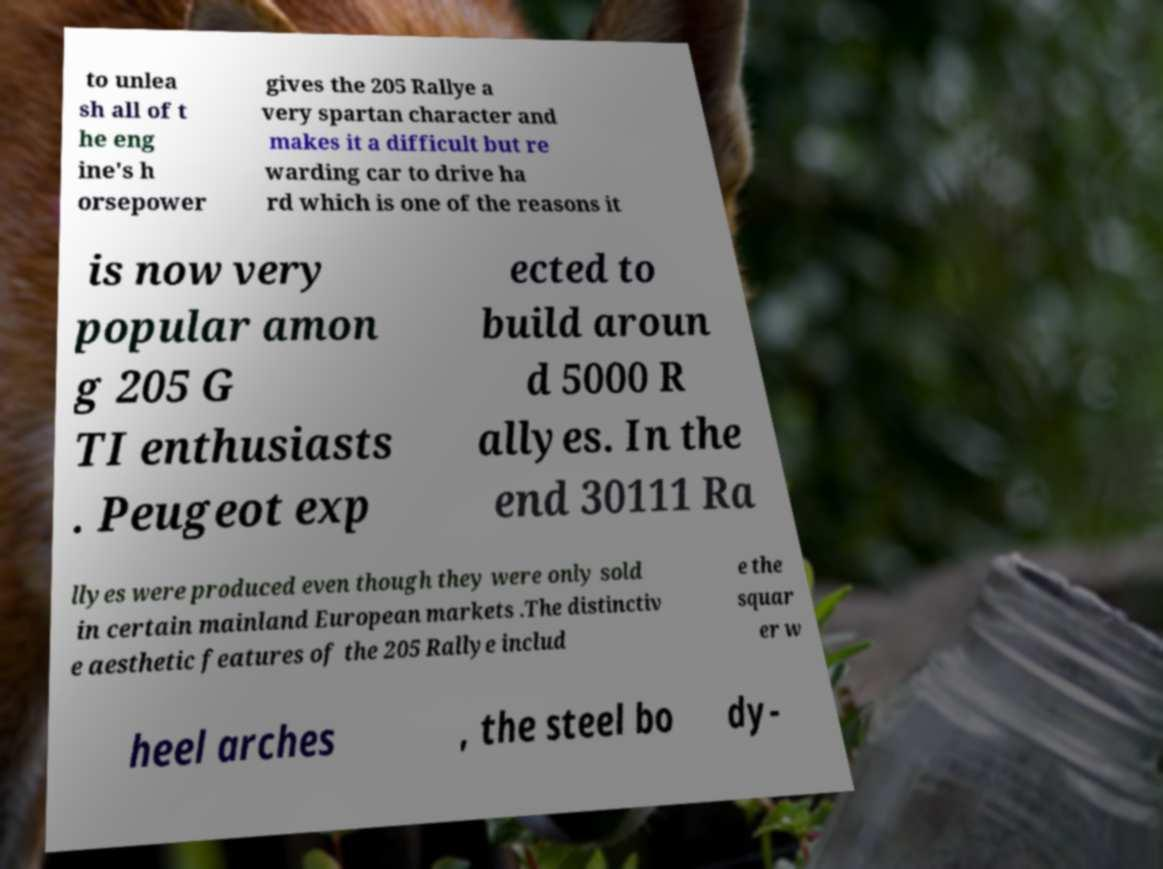There's text embedded in this image that I need extracted. Can you transcribe it verbatim? to unlea sh all of t he eng ine's h orsepower gives the 205 Rallye a very spartan character and makes it a difficult but re warding car to drive ha rd which is one of the reasons it is now very popular amon g 205 G TI enthusiasts . Peugeot exp ected to build aroun d 5000 R allyes. In the end 30111 Ra llyes were produced even though they were only sold in certain mainland European markets .The distinctiv e aesthetic features of the 205 Rallye includ e the squar er w heel arches , the steel bo dy- 